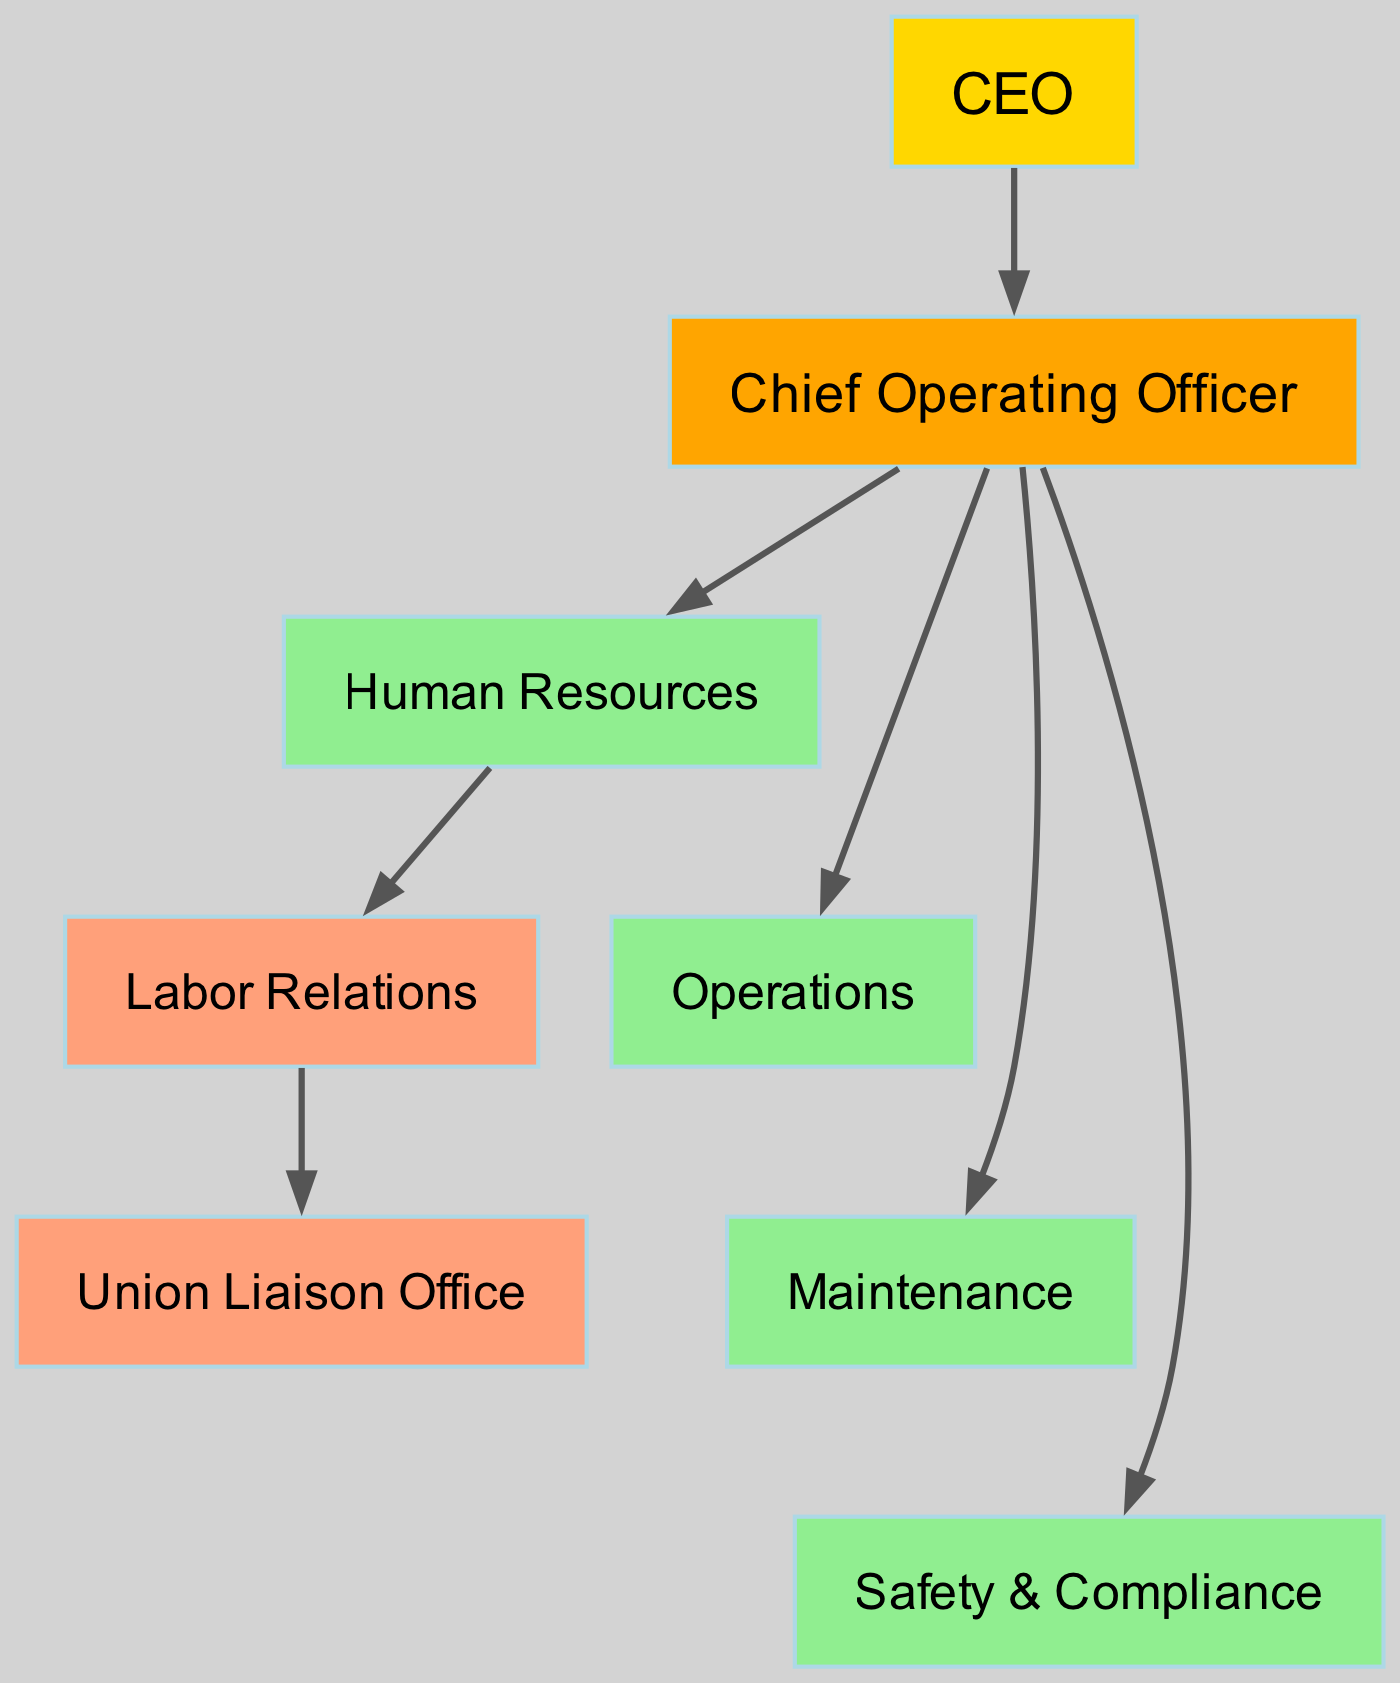What is the top position in the organizational structure? The top position is represented by the CEO node, which is the highest authority within the company according to the diagram.
Answer: CEO How many departments report directly to the COO? In the diagram, there are four edges leading from the COO to HR, Operations, Maintenance, and Safety, indicating that these four departments report directly to the COO.
Answer: 4 Which department handles Labor Relations? The Labor Relations department is depicted as a node that reports to HR, which indicates it is managed under the Human Resources department.
Answer: Labor Relations Who does the Labor Relations department communicate with? The Labor Relations department has a direct edge to the Union Liaison Office, showing that it communicates specifically with this office regarding union-related matters.
Answer: Union Liaison Office Which department is responsible for Safety? The Safety department is one of the nodes connected directly to the COO, indicating that it is responsible for safety and compliance matters within the organization.
Answer: Safety & Compliance What type of edge connects HR to Labor Relations? The edge connecting HR to Labor Relations is a direct reporting line, indicating that Labor Relations falls under the HR department's jurisdiction as shown in the diagram.
Answer: Direct How many nodes are present in the diagram? To find the number of nodes, count each unique box in the diagram, which totals to eight distinct roles or departments as outlined.
Answer: 8 Is there any department that directly reports to the CEO? The diagram shows that the COO directly reports to the CEO, meaning there are no departments reporting directly from the CEO except through the COO.
Answer: No What color represents the COO in the diagram? The COO node is depicted in orange in the diagram, which differentiates it from other departments visually.
Answer: Orange What is the relationship between Operations and Maintenance? Operations and Maintenance are connected by a direct reporting line from COO to both, indicating there is parallel reporting but no direct connection indicated in the diagram between Operations and Maintenance.
Answer: No direct connection 